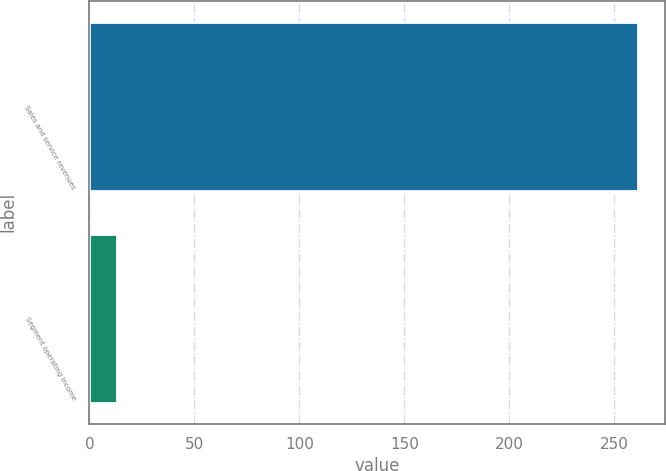<chart> <loc_0><loc_0><loc_500><loc_500><bar_chart><fcel>Sales and service revenues<fcel>Segment operating income<nl><fcel>261<fcel>13<nl></chart> 